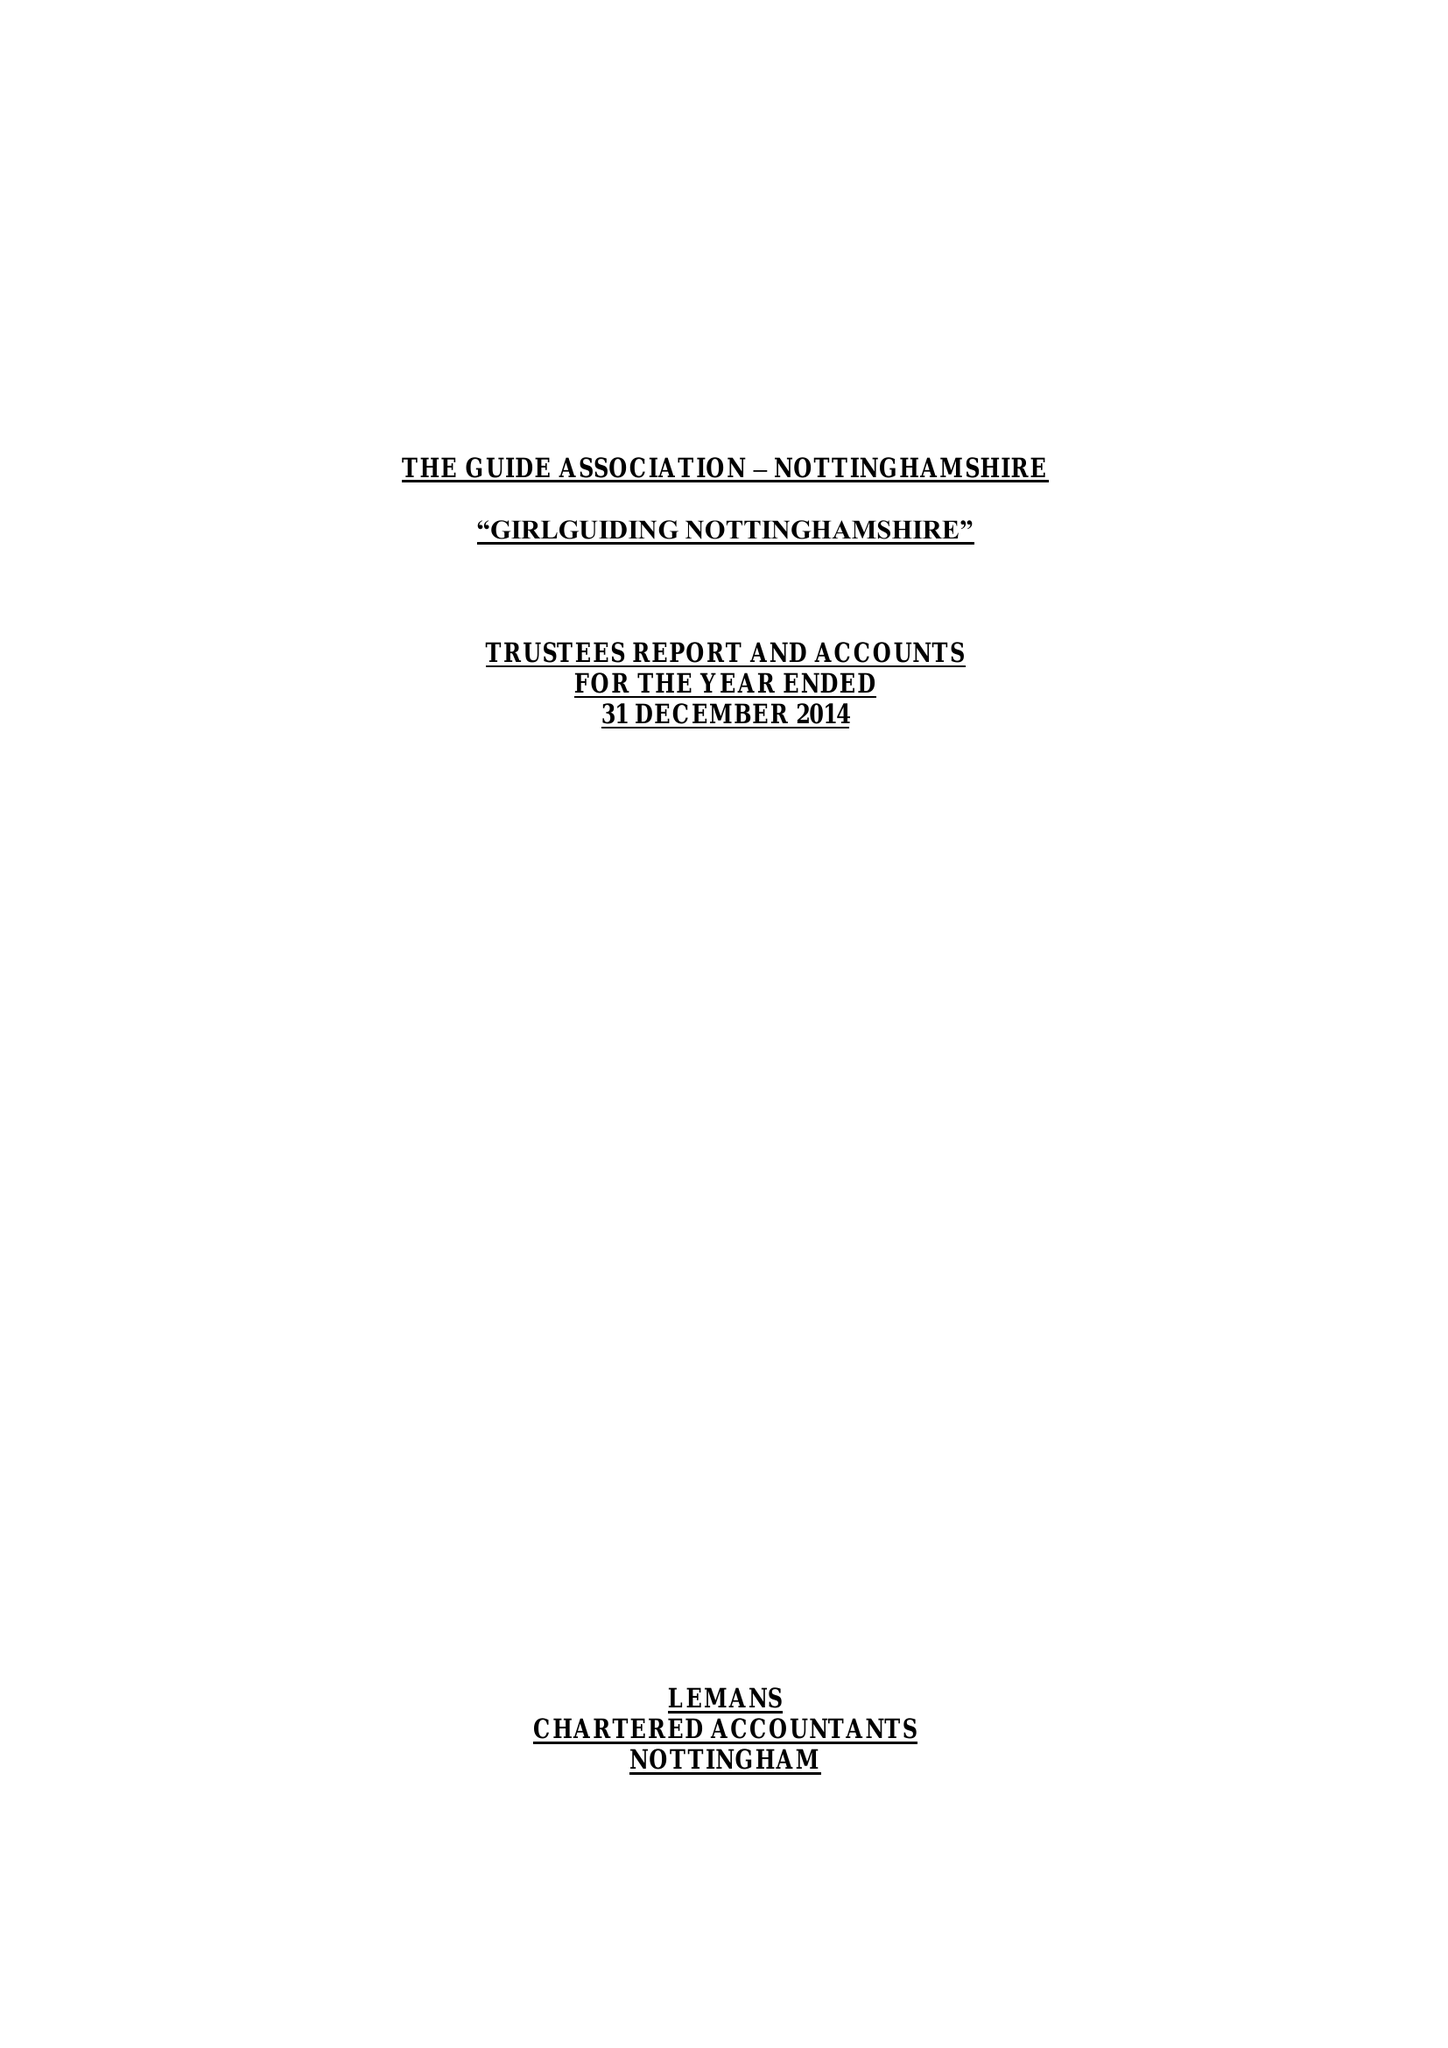What is the value for the income_annually_in_british_pounds?
Answer the question using a single word or phrase. 269234.00 